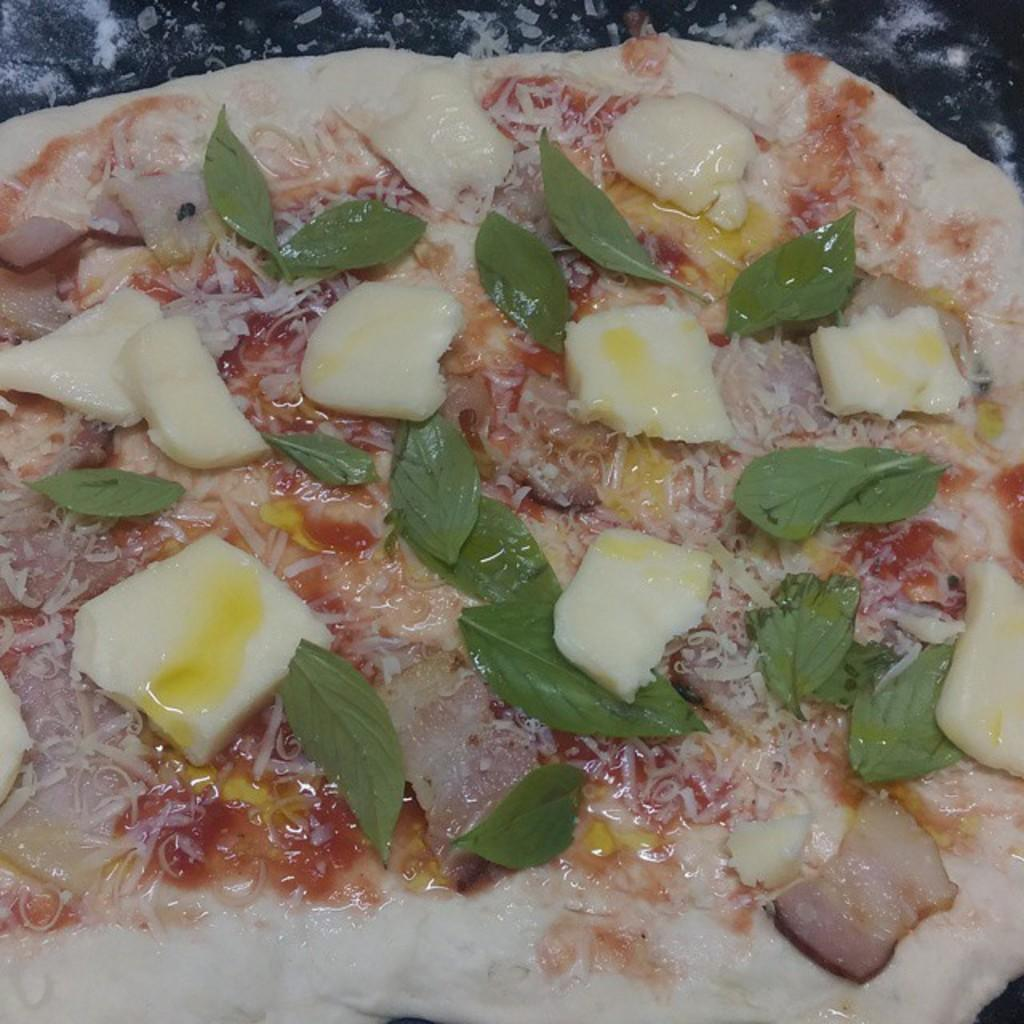What is the main food item visible in the image? There is a pizza in the image. What additional topping can be seen on the pizza? There are green leaves on top of the pizza. What type of cap is the pizza wearing in the image? The pizza is not wearing a cap, as it is a food item and not a person or animate object. 